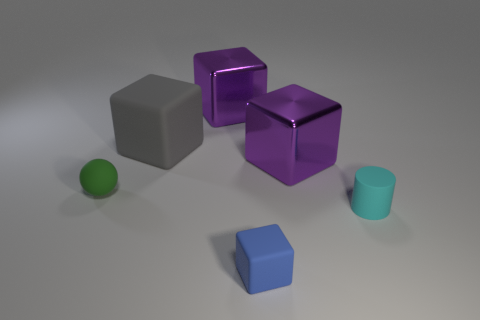How many tiny cyan objects are there?
Ensure brevity in your answer.  1. There is a large purple thing in front of the purple thing that is left of the blue matte object; what is it made of?
Your answer should be compact. Metal. Does the rubber block that is in front of the gray cube have the same size as the large gray rubber thing?
Make the answer very short. No. There is a rubber thing in front of the cyan cylinder; does it have the same shape as the big gray object?
Provide a short and direct response. Yes. What number of things are either tiny things or rubber things behind the tiny cyan object?
Give a very brief answer. 4. Are there fewer large purple objects than large green balls?
Keep it short and to the point. No. Are there more tiny matte balls than tiny gray metal objects?
Make the answer very short. Yes. How many other things are made of the same material as the blue block?
Offer a terse response. 3. How many big blocks are left of the matte block that is behind the purple shiny thing that is right of the small blue rubber block?
Ensure brevity in your answer.  0. What number of metal objects are either big blue things or cyan objects?
Give a very brief answer. 0. 